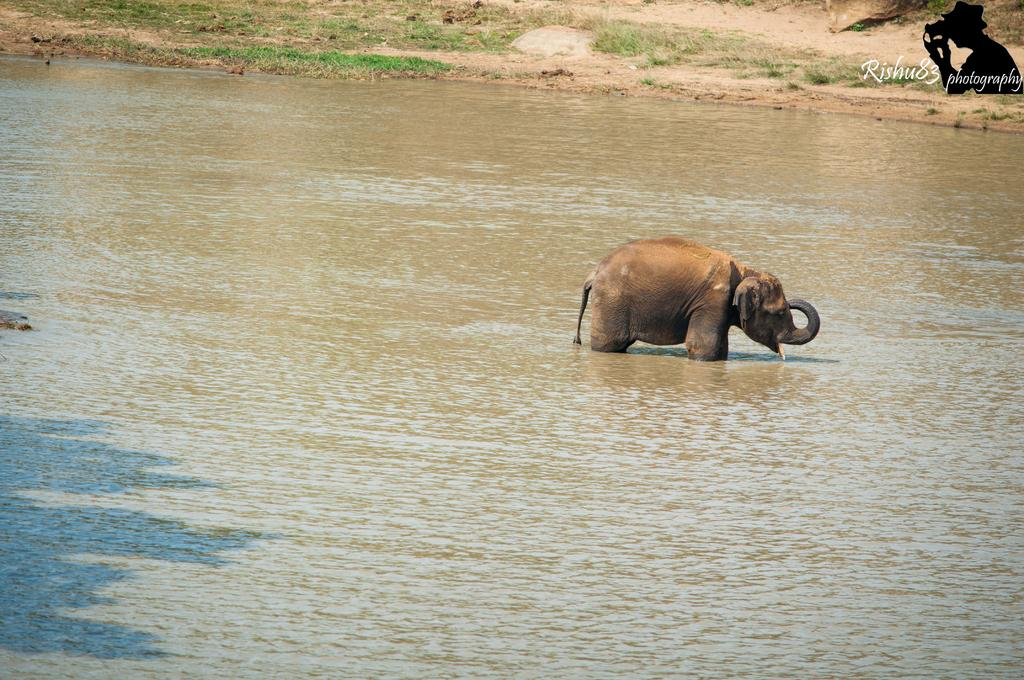What animal is in the water in the image? There is an elephant in the water in the image. What type of vegetation can be seen in the image? There is grass visible in the image. What type of surface is visible in the image? There is ground visible in the image. What can be seen in the top right side of the image? In the top right side of the image, there is an image of a person and text. Which direction is the wave coming from in the image? There is no wave present in the image. What is the elephant using to communicate with the person in the image? The elephant does not have a mouth or any other means of communication visible in the image. 